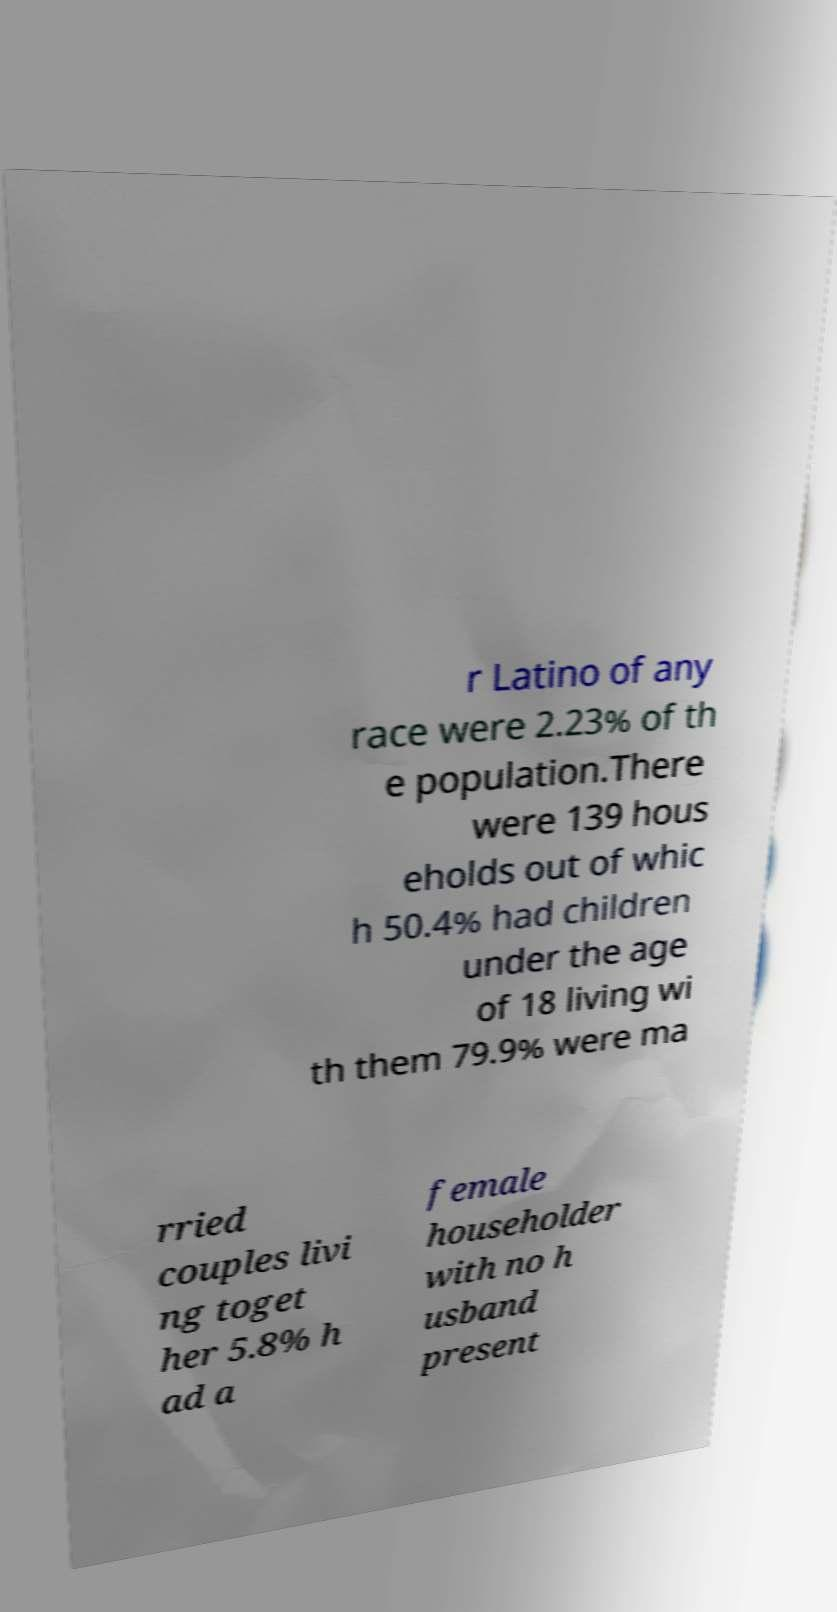What messages or text are displayed in this image? I need them in a readable, typed format. r Latino of any race were 2.23% of th e population.There were 139 hous eholds out of whic h 50.4% had children under the age of 18 living wi th them 79.9% were ma rried couples livi ng toget her 5.8% h ad a female householder with no h usband present 